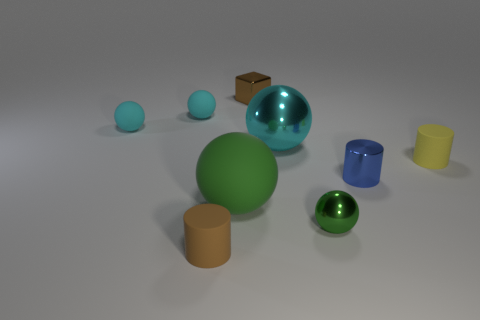Subtract all red cubes. How many cyan balls are left? 3 Subtract all big cyan shiny balls. How many balls are left? 4 Subtract all red spheres. Subtract all yellow blocks. How many spheres are left? 5 Add 1 small brown shiny spheres. How many objects exist? 10 Subtract all cylinders. How many objects are left? 6 Add 7 big balls. How many big balls are left? 9 Add 3 brown cubes. How many brown cubes exist? 4 Subtract 1 yellow cylinders. How many objects are left? 8 Subtract all small gray rubber cylinders. Subtract all matte objects. How many objects are left? 4 